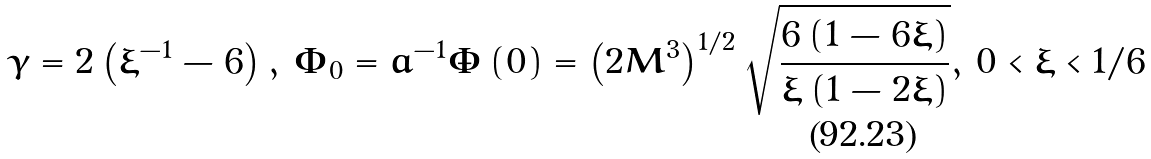<formula> <loc_0><loc_0><loc_500><loc_500>\gamma = 2 \left ( { \xi ^ { - 1 } - 6 } \right ) , \, \Phi _ { 0 } = a ^ { - 1 } \dot { \Phi } \left ( 0 \right ) = \left ( { 2 M ^ { 3 } } \right ) ^ { 1 / 2 } \sqrt { \frac { { 6 \left ( { 1 - 6 \xi } \right ) } } { { \xi \left ( { 1 - 2 \xi } \right ) } } } , \, 0 < \xi < 1 / 6</formula> 